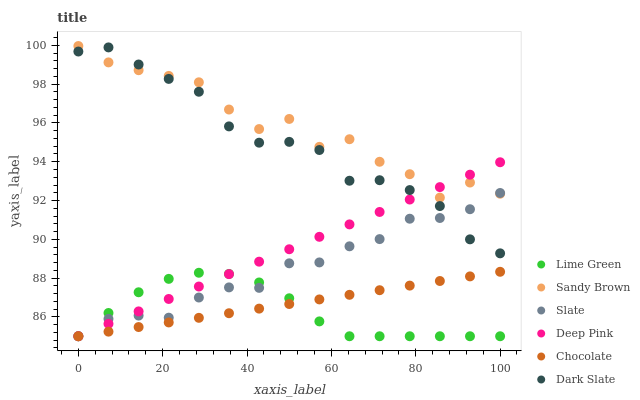Does Lime Green have the minimum area under the curve?
Answer yes or no. Yes. Does Sandy Brown have the maximum area under the curve?
Answer yes or no. Yes. Does Slate have the minimum area under the curve?
Answer yes or no. No. Does Slate have the maximum area under the curve?
Answer yes or no. No. Is Deep Pink the smoothest?
Answer yes or no. Yes. Is Sandy Brown the roughest?
Answer yes or no. Yes. Is Lime Green the smoothest?
Answer yes or no. No. Is Lime Green the roughest?
Answer yes or no. No. Does Deep Pink have the lowest value?
Answer yes or no. Yes. Does Dark Slate have the lowest value?
Answer yes or no. No. Does Sandy Brown have the highest value?
Answer yes or no. Yes. Does Slate have the highest value?
Answer yes or no. No. Is Lime Green less than Sandy Brown?
Answer yes or no. Yes. Is Dark Slate greater than Chocolate?
Answer yes or no. Yes. Does Lime Green intersect Chocolate?
Answer yes or no. Yes. Is Lime Green less than Chocolate?
Answer yes or no. No. Is Lime Green greater than Chocolate?
Answer yes or no. No. Does Lime Green intersect Sandy Brown?
Answer yes or no. No. 